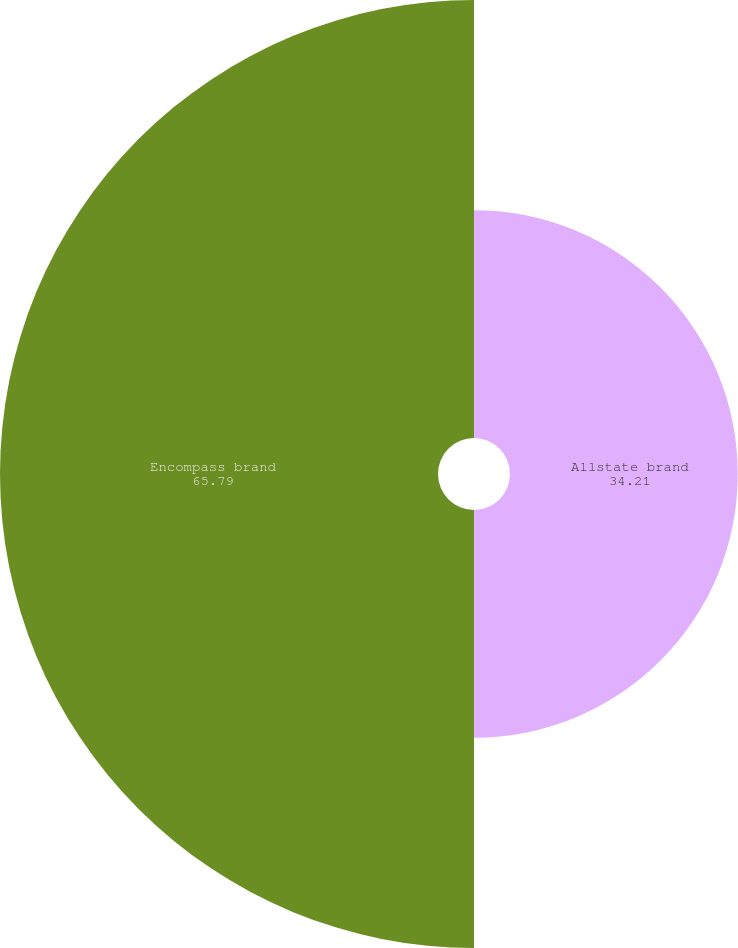Convert chart. <chart><loc_0><loc_0><loc_500><loc_500><pie_chart><fcel>Allstate brand<fcel>Encompass brand<nl><fcel>34.21%<fcel>65.79%<nl></chart> 